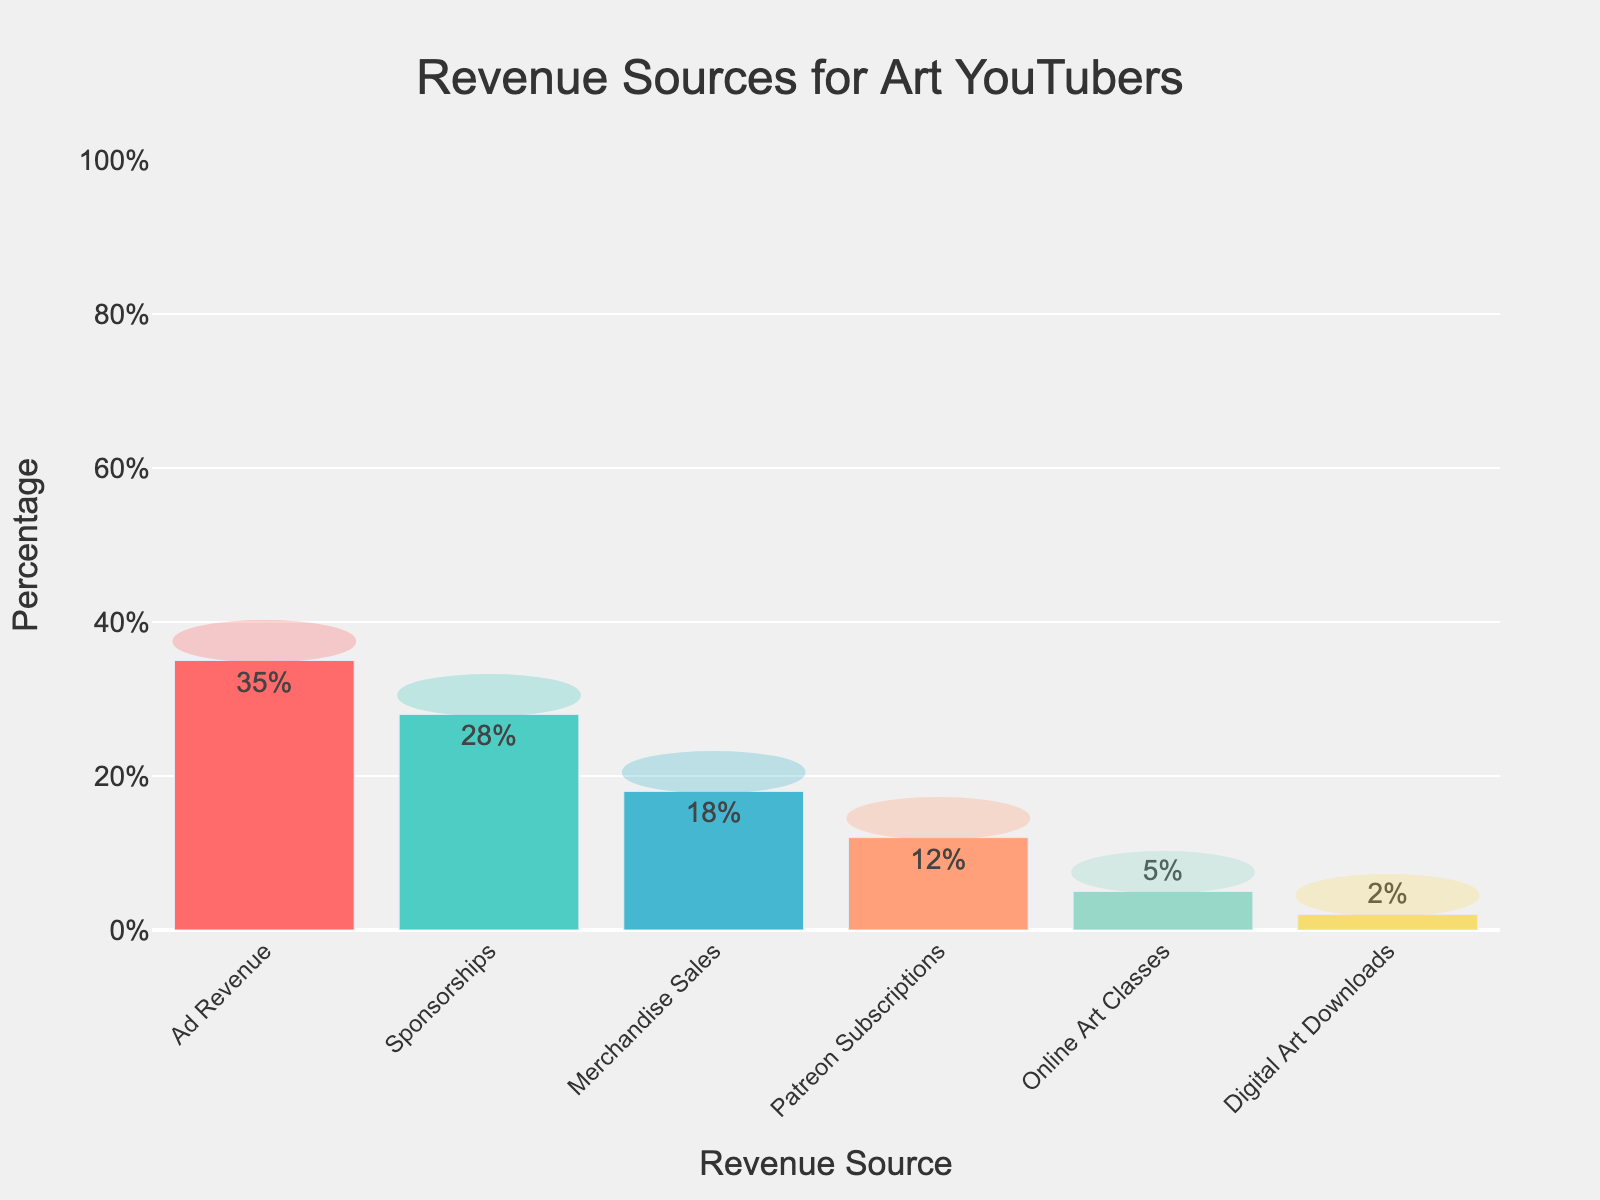What's the largest source of revenue for art YouTubers? The tallest bar in the chart represents Ad Revenue, which is at 35%.
Answer: Ad Revenue Which revenue source brings in the least percentage? The shortest bar in the chart represents Digital Art Downloads, which is at 2%.
Answer: Digital Art Downloads How much more revenue percentage do Sponsorships generate compared to Online Art Classes? Sponsorships are at 28% and Online Art Classes are at 5%. Subtracting the smaller percentage from the larger gives 28% - 5% = 23%.
Answer: 23% What is the combined percentage of revenue from Ad Revenue and Patreon Subscriptions? Ad Revenue is 35% and Patreon Subscriptions are 12%. Adding these gives 35% + 12% = 47%.
Answer: 47% Which revenue source is closest in percentage to Merchandise Sales? Merchandise Sales are at 18%, and the closest is Sponsorships at 28%, being a difference of 10%, followed by Patreon Subscriptions at 12%, being a difference of 6%. So, Patreon Subscriptions are closest.
Answer: Patreon Subscriptions Out of the top three revenue sources, which one is in the middle position by percentage? The top three revenue sources by percentage are Ad Revenue (35%), Sponsorships (28%), and Merchandise Sales (18%). Sponsorships, with 28%, falls in the middle.
Answer: Sponsorships Are there more revenue sources with a percentage below 10% or above 20%? Revenue sources below 10% are Digital Art Downloads (2%) and Online Art Classes (5%), totaling 2. Revenue sources above 20% are Ad Revenue (35%) and Sponsorships (28%), totaling 2. Therefore, they are equal.
Answer: Equal 